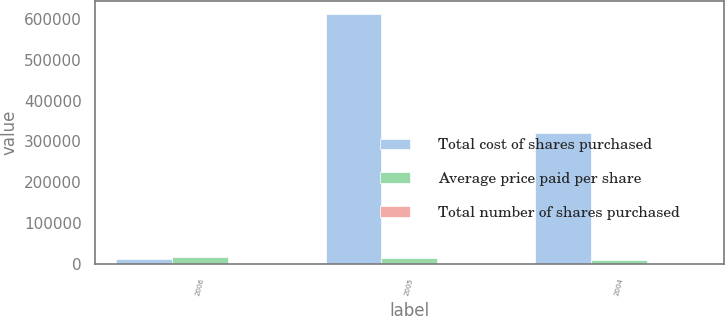Convert chart. <chart><loc_0><loc_0><loc_500><loc_500><stacked_bar_chart><ecel><fcel>2006<fcel>2005<fcel>2004<nl><fcel>Total cost of shares purchased<fcel>12785.6<fcel>611641<fcel>320224<nl><fcel>Average price paid per share<fcel>17992.7<fcel>15274.8<fcel>10296.4<nl><fcel>Total number of shares purchased<fcel>59.35<fcel>40.04<fcel>31.1<nl></chart> 